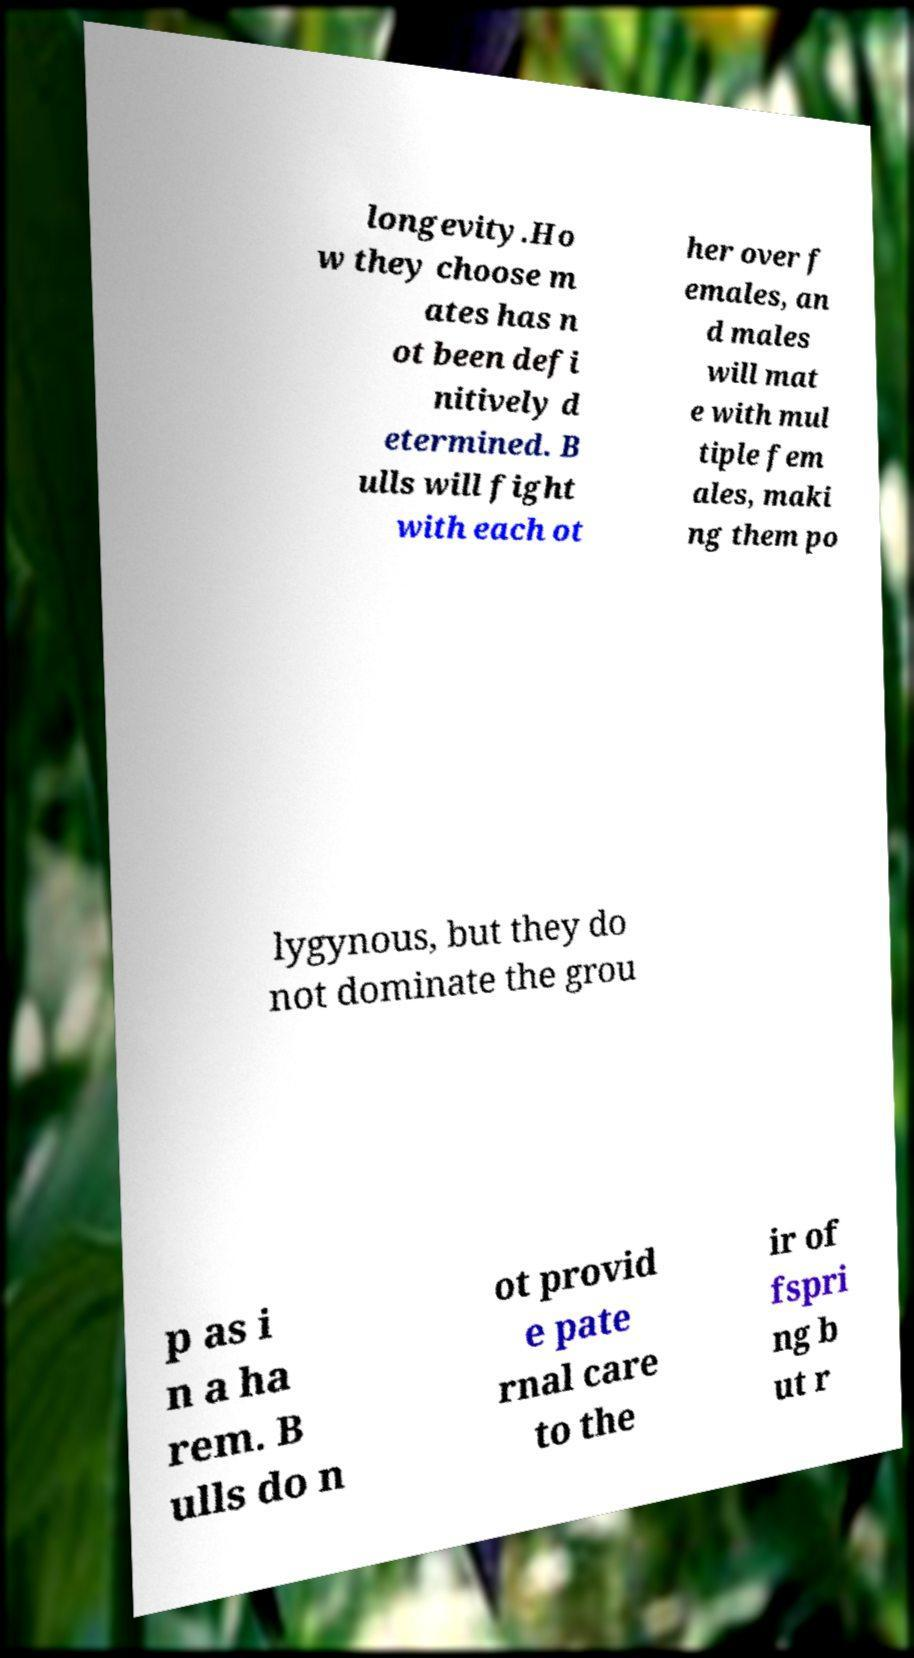Please read and relay the text visible in this image. What does it say? longevity.Ho w they choose m ates has n ot been defi nitively d etermined. B ulls will fight with each ot her over f emales, an d males will mat e with mul tiple fem ales, maki ng them po lygynous, but they do not dominate the grou p as i n a ha rem. B ulls do n ot provid e pate rnal care to the ir of fspri ng b ut r 